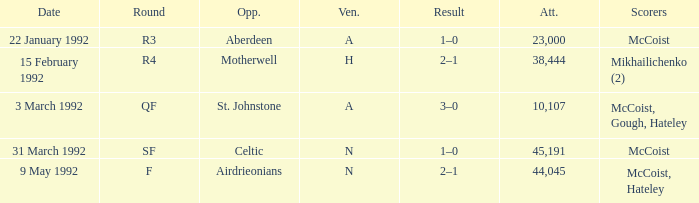What is the result of round R3? 1–0. 